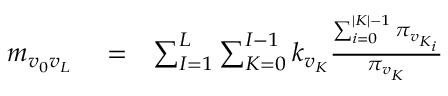<formula> <loc_0><loc_0><loc_500><loc_500>\begin{array} { r l r } { m _ { v _ { 0 } v _ { L } } } & = } & { \sum _ { I = 1 } ^ { L } \sum _ { K = 0 } ^ { I - 1 } k _ { v _ { K } } \frac { \sum _ { i = 0 } ^ { | K | - 1 } \pi _ { v _ { K _ { i } } } } { \pi _ { v _ { K } } } } \end{array}</formula> 